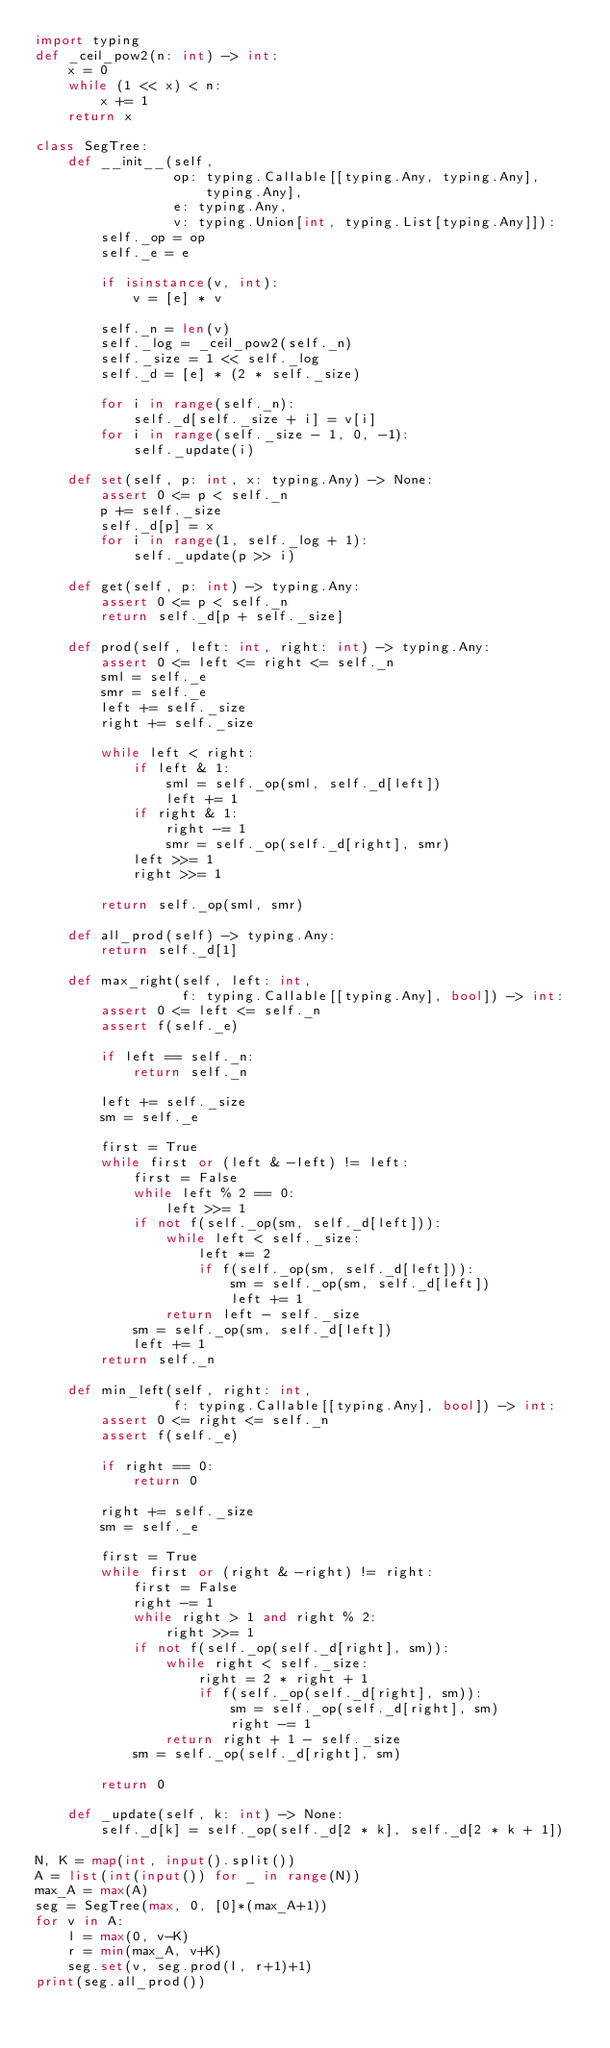<code> <loc_0><loc_0><loc_500><loc_500><_Python_>import typing
def _ceil_pow2(n: int) -> int:
    x = 0
    while (1 << x) < n:
        x += 1
    return x

class SegTree:
    def __init__(self,
                 op: typing.Callable[[typing.Any, typing.Any], typing.Any],
                 e: typing.Any,
                 v: typing.Union[int, typing.List[typing.Any]]):
        self._op = op
        self._e = e

        if isinstance(v, int):
            v = [e] * v

        self._n = len(v)
        self._log = _ceil_pow2(self._n)
        self._size = 1 << self._log
        self._d = [e] * (2 * self._size)

        for i in range(self._n):
            self._d[self._size + i] = v[i]
        for i in range(self._size - 1, 0, -1):
            self._update(i)
    
    def set(self, p: int, x: typing.Any) -> None:
        assert 0 <= p < self._n
        p += self._size
        self._d[p] = x
        for i in range(1, self._log + 1):
            self._update(p >> i)

    def get(self, p: int) -> typing.Any:
        assert 0 <= p < self._n
        return self._d[p + self._size]

    def prod(self, left: int, right: int) -> typing.Any:
        assert 0 <= left <= right <= self._n
        sml = self._e
        smr = self._e
        left += self._size
        right += self._size

        while left < right:
            if left & 1:
                sml = self._op(sml, self._d[left])
                left += 1
            if right & 1:
                right -= 1
                smr = self._op(self._d[right], smr)
            left >>= 1
            right >>= 1

        return self._op(sml, smr)

    def all_prod(self) -> typing.Any:
        return self._d[1]

    def max_right(self, left: int,
                  f: typing.Callable[[typing.Any], bool]) -> int:
        assert 0 <= left <= self._n
        assert f(self._e)

        if left == self._n:
            return self._n

        left += self._size
        sm = self._e

        first = True
        while first or (left & -left) != left:
            first = False
            while left % 2 == 0:
                left >>= 1
            if not f(self._op(sm, self._d[left])):
                while left < self._size:
                    left *= 2
                    if f(self._op(sm, self._d[left])):
                        sm = self._op(sm, self._d[left])
                        left += 1
                return left - self._size
            sm = self._op(sm, self._d[left])
            left += 1
        return self._n

    def min_left(self, right: int,
                 f: typing.Callable[[typing.Any], bool]) -> int:
        assert 0 <= right <= self._n
        assert f(self._e)

        if right == 0:
            return 0

        right += self._size
        sm = self._e

        first = True
        while first or (right & -right) != right:
            first = False
            right -= 1
            while right > 1 and right % 2:
                right >>= 1
            if not f(self._op(self._d[right], sm)):
                while right < self._size:
                    right = 2 * right + 1
                    if f(self._op(self._d[right], sm)):
                        sm = self._op(self._d[right], sm)
                        right -= 1
                return right + 1 - self._size
            sm = self._op(self._d[right], sm)

        return 0

    def _update(self, k: int) -> None:
        self._d[k] = self._op(self._d[2 * k], self._d[2 * k + 1])

N, K = map(int, input().split())
A = list(int(input()) for _ in range(N))
max_A = max(A)
seg = SegTree(max, 0, [0]*(max_A+1))
for v in A:
    l = max(0, v-K)
    r = min(max_A, v+K)
    seg.set(v, seg.prod(l, r+1)+1)
print(seg.all_prod())</code> 